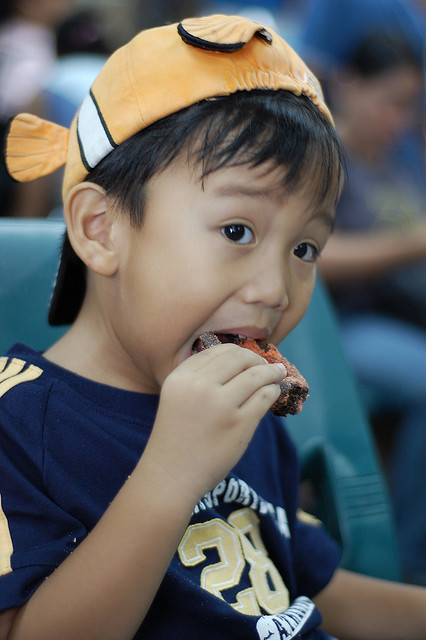<image>Is the kid eating food? I am not sure if the kid is eating food. It might be seen that the kid is eating a sandwich. Is the kid eating food? I don't know if the kid is eating food. It can be both yes or no. 